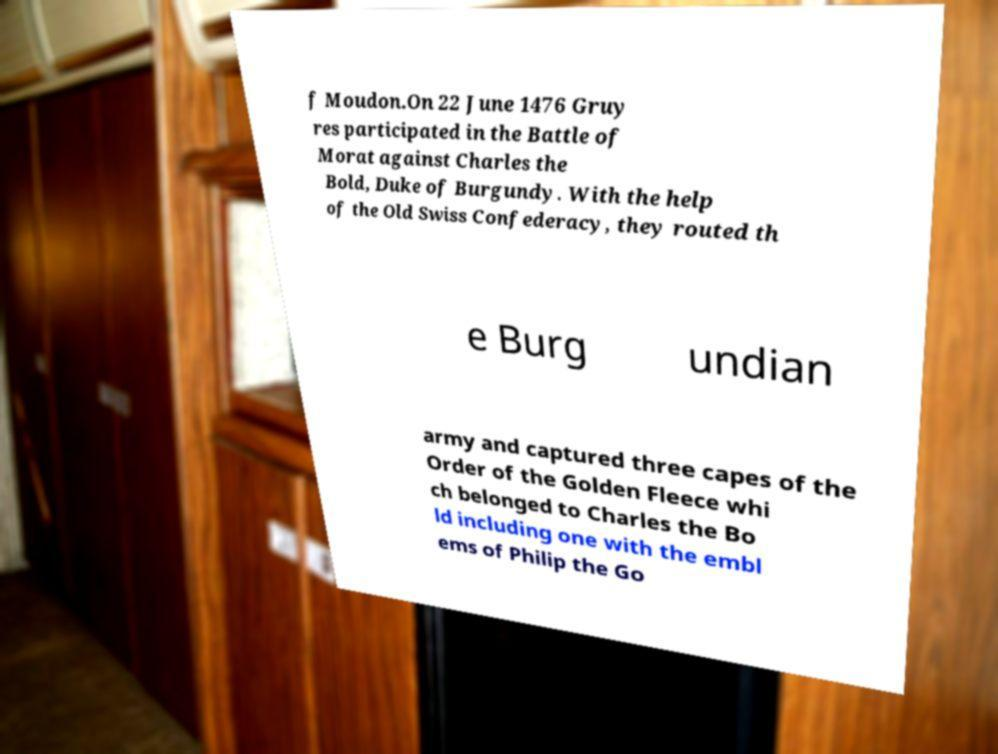I need the written content from this picture converted into text. Can you do that? f Moudon.On 22 June 1476 Gruy res participated in the Battle of Morat against Charles the Bold, Duke of Burgundy. With the help of the Old Swiss Confederacy, they routed th e Burg undian army and captured three capes of the Order of the Golden Fleece whi ch belonged to Charles the Bo ld including one with the embl ems of Philip the Go 